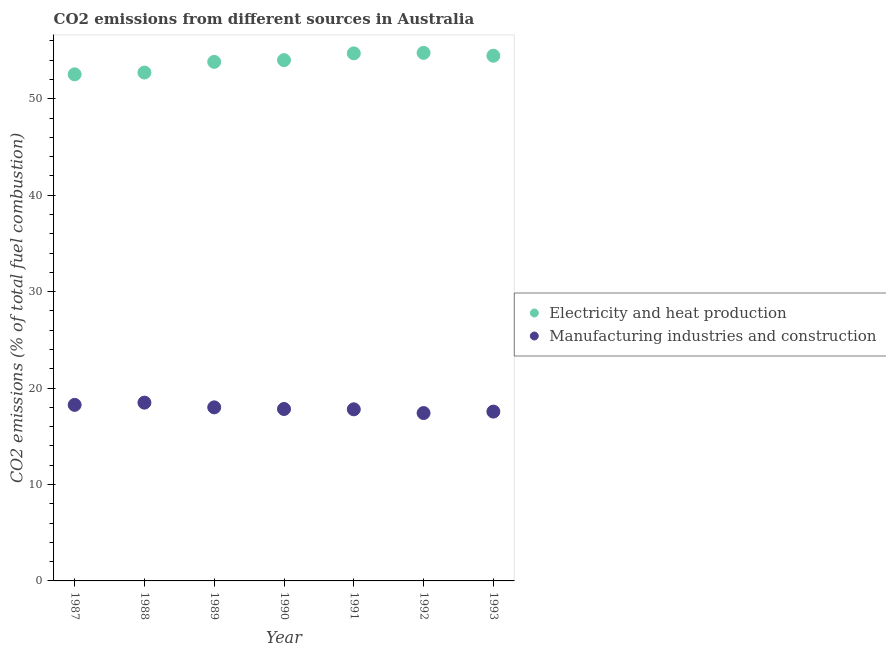Is the number of dotlines equal to the number of legend labels?
Offer a terse response. Yes. What is the co2 emissions due to electricity and heat production in 1993?
Offer a very short reply. 54.46. Across all years, what is the maximum co2 emissions due to electricity and heat production?
Keep it short and to the point. 54.75. Across all years, what is the minimum co2 emissions due to electricity and heat production?
Keep it short and to the point. 52.53. In which year was the co2 emissions due to electricity and heat production maximum?
Give a very brief answer. 1992. What is the total co2 emissions due to electricity and heat production in the graph?
Offer a very short reply. 376.98. What is the difference between the co2 emissions due to manufacturing industries in 1990 and that in 1993?
Offer a terse response. 0.27. What is the difference between the co2 emissions due to manufacturing industries in 1989 and the co2 emissions due to electricity and heat production in 1988?
Ensure brevity in your answer.  -34.72. What is the average co2 emissions due to manufacturing industries per year?
Offer a terse response. 17.9. In the year 1992, what is the difference between the co2 emissions due to manufacturing industries and co2 emissions due to electricity and heat production?
Ensure brevity in your answer.  -37.35. What is the ratio of the co2 emissions due to manufacturing industries in 1989 to that in 1993?
Offer a very short reply. 1.03. Is the co2 emissions due to manufacturing industries in 1989 less than that in 1991?
Offer a terse response. No. Is the difference between the co2 emissions due to manufacturing industries in 1987 and 1989 greater than the difference between the co2 emissions due to electricity and heat production in 1987 and 1989?
Keep it short and to the point. Yes. What is the difference between the highest and the second highest co2 emissions due to manufacturing industries?
Provide a succinct answer. 0.23. What is the difference between the highest and the lowest co2 emissions due to manufacturing industries?
Give a very brief answer. 1.08. Does the co2 emissions due to electricity and heat production monotonically increase over the years?
Offer a terse response. No. Is the co2 emissions due to manufacturing industries strictly greater than the co2 emissions due to electricity and heat production over the years?
Your answer should be very brief. No. How many years are there in the graph?
Ensure brevity in your answer.  7. Are the values on the major ticks of Y-axis written in scientific E-notation?
Provide a succinct answer. No. Where does the legend appear in the graph?
Offer a terse response. Center right. What is the title of the graph?
Keep it short and to the point. CO2 emissions from different sources in Australia. Does "Secondary Education" appear as one of the legend labels in the graph?
Give a very brief answer. No. What is the label or title of the Y-axis?
Your answer should be compact. CO2 emissions (% of total fuel combustion). What is the CO2 emissions (% of total fuel combustion) of Electricity and heat production in 1987?
Make the answer very short. 52.53. What is the CO2 emissions (% of total fuel combustion) of Manufacturing industries and construction in 1987?
Keep it short and to the point. 18.26. What is the CO2 emissions (% of total fuel combustion) of Electricity and heat production in 1988?
Your response must be concise. 52.71. What is the CO2 emissions (% of total fuel combustion) of Manufacturing industries and construction in 1988?
Offer a terse response. 18.49. What is the CO2 emissions (% of total fuel combustion) in Electricity and heat production in 1989?
Give a very brief answer. 53.82. What is the CO2 emissions (% of total fuel combustion) in Manufacturing industries and construction in 1989?
Ensure brevity in your answer.  18. What is the CO2 emissions (% of total fuel combustion) of Electricity and heat production in 1990?
Give a very brief answer. 54. What is the CO2 emissions (% of total fuel combustion) in Manufacturing industries and construction in 1990?
Offer a very short reply. 17.83. What is the CO2 emissions (% of total fuel combustion) in Electricity and heat production in 1991?
Offer a terse response. 54.7. What is the CO2 emissions (% of total fuel combustion) of Manufacturing industries and construction in 1991?
Give a very brief answer. 17.79. What is the CO2 emissions (% of total fuel combustion) of Electricity and heat production in 1992?
Offer a very short reply. 54.75. What is the CO2 emissions (% of total fuel combustion) in Manufacturing industries and construction in 1992?
Your answer should be compact. 17.41. What is the CO2 emissions (% of total fuel combustion) in Electricity and heat production in 1993?
Your answer should be very brief. 54.46. What is the CO2 emissions (% of total fuel combustion) in Manufacturing industries and construction in 1993?
Your answer should be compact. 17.56. Across all years, what is the maximum CO2 emissions (% of total fuel combustion) of Electricity and heat production?
Give a very brief answer. 54.75. Across all years, what is the maximum CO2 emissions (% of total fuel combustion) in Manufacturing industries and construction?
Provide a succinct answer. 18.49. Across all years, what is the minimum CO2 emissions (% of total fuel combustion) in Electricity and heat production?
Give a very brief answer. 52.53. Across all years, what is the minimum CO2 emissions (% of total fuel combustion) of Manufacturing industries and construction?
Make the answer very short. 17.41. What is the total CO2 emissions (% of total fuel combustion) in Electricity and heat production in the graph?
Ensure brevity in your answer.  376.98. What is the total CO2 emissions (% of total fuel combustion) in Manufacturing industries and construction in the graph?
Provide a short and direct response. 125.32. What is the difference between the CO2 emissions (% of total fuel combustion) in Electricity and heat production in 1987 and that in 1988?
Keep it short and to the point. -0.19. What is the difference between the CO2 emissions (% of total fuel combustion) of Manufacturing industries and construction in 1987 and that in 1988?
Your answer should be very brief. -0.23. What is the difference between the CO2 emissions (% of total fuel combustion) of Electricity and heat production in 1987 and that in 1989?
Keep it short and to the point. -1.29. What is the difference between the CO2 emissions (% of total fuel combustion) in Manufacturing industries and construction in 1987 and that in 1989?
Keep it short and to the point. 0.26. What is the difference between the CO2 emissions (% of total fuel combustion) of Electricity and heat production in 1987 and that in 1990?
Provide a short and direct response. -1.47. What is the difference between the CO2 emissions (% of total fuel combustion) of Manufacturing industries and construction in 1987 and that in 1990?
Your answer should be compact. 0.43. What is the difference between the CO2 emissions (% of total fuel combustion) of Electricity and heat production in 1987 and that in 1991?
Provide a succinct answer. -2.18. What is the difference between the CO2 emissions (% of total fuel combustion) of Manufacturing industries and construction in 1987 and that in 1991?
Your answer should be very brief. 0.46. What is the difference between the CO2 emissions (% of total fuel combustion) in Electricity and heat production in 1987 and that in 1992?
Keep it short and to the point. -2.22. What is the difference between the CO2 emissions (% of total fuel combustion) of Manufacturing industries and construction in 1987 and that in 1992?
Your answer should be very brief. 0.85. What is the difference between the CO2 emissions (% of total fuel combustion) of Electricity and heat production in 1987 and that in 1993?
Provide a short and direct response. -1.93. What is the difference between the CO2 emissions (% of total fuel combustion) in Manufacturing industries and construction in 1987 and that in 1993?
Your answer should be very brief. 0.7. What is the difference between the CO2 emissions (% of total fuel combustion) of Electricity and heat production in 1988 and that in 1989?
Provide a succinct answer. -1.11. What is the difference between the CO2 emissions (% of total fuel combustion) in Manufacturing industries and construction in 1988 and that in 1989?
Ensure brevity in your answer.  0.49. What is the difference between the CO2 emissions (% of total fuel combustion) in Electricity and heat production in 1988 and that in 1990?
Your answer should be compact. -1.29. What is the difference between the CO2 emissions (% of total fuel combustion) of Manufacturing industries and construction in 1988 and that in 1990?
Offer a very short reply. 0.66. What is the difference between the CO2 emissions (% of total fuel combustion) of Electricity and heat production in 1988 and that in 1991?
Your answer should be very brief. -1.99. What is the difference between the CO2 emissions (% of total fuel combustion) in Manufacturing industries and construction in 1988 and that in 1991?
Make the answer very short. 0.69. What is the difference between the CO2 emissions (% of total fuel combustion) in Electricity and heat production in 1988 and that in 1992?
Your answer should be very brief. -2.04. What is the difference between the CO2 emissions (% of total fuel combustion) of Manufacturing industries and construction in 1988 and that in 1992?
Your response must be concise. 1.08. What is the difference between the CO2 emissions (% of total fuel combustion) of Electricity and heat production in 1988 and that in 1993?
Provide a succinct answer. -1.74. What is the difference between the CO2 emissions (% of total fuel combustion) of Manufacturing industries and construction in 1988 and that in 1993?
Make the answer very short. 0.93. What is the difference between the CO2 emissions (% of total fuel combustion) of Electricity and heat production in 1989 and that in 1990?
Provide a succinct answer. -0.18. What is the difference between the CO2 emissions (% of total fuel combustion) in Manufacturing industries and construction in 1989 and that in 1990?
Your response must be concise. 0.17. What is the difference between the CO2 emissions (% of total fuel combustion) in Electricity and heat production in 1989 and that in 1991?
Give a very brief answer. -0.88. What is the difference between the CO2 emissions (% of total fuel combustion) of Manufacturing industries and construction in 1989 and that in 1991?
Keep it short and to the point. 0.2. What is the difference between the CO2 emissions (% of total fuel combustion) of Electricity and heat production in 1989 and that in 1992?
Provide a short and direct response. -0.93. What is the difference between the CO2 emissions (% of total fuel combustion) of Manufacturing industries and construction in 1989 and that in 1992?
Keep it short and to the point. 0.59. What is the difference between the CO2 emissions (% of total fuel combustion) of Electricity and heat production in 1989 and that in 1993?
Provide a short and direct response. -0.63. What is the difference between the CO2 emissions (% of total fuel combustion) in Manufacturing industries and construction in 1989 and that in 1993?
Offer a very short reply. 0.44. What is the difference between the CO2 emissions (% of total fuel combustion) of Electricity and heat production in 1990 and that in 1991?
Ensure brevity in your answer.  -0.7. What is the difference between the CO2 emissions (% of total fuel combustion) in Manufacturing industries and construction in 1990 and that in 1991?
Offer a very short reply. 0.03. What is the difference between the CO2 emissions (% of total fuel combustion) of Electricity and heat production in 1990 and that in 1992?
Offer a terse response. -0.75. What is the difference between the CO2 emissions (% of total fuel combustion) of Manufacturing industries and construction in 1990 and that in 1992?
Offer a terse response. 0.42. What is the difference between the CO2 emissions (% of total fuel combustion) in Electricity and heat production in 1990 and that in 1993?
Your answer should be compact. -0.46. What is the difference between the CO2 emissions (% of total fuel combustion) of Manufacturing industries and construction in 1990 and that in 1993?
Keep it short and to the point. 0.27. What is the difference between the CO2 emissions (% of total fuel combustion) of Electricity and heat production in 1991 and that in 1992?
Your answer should be compact. -0.05. What is the difference between the CO2 emissions (% of total fuel combustion) of Manufacturing industries and construction in 1991 and that in 1992?
Give a very brief answer. 0.39. What is the difference between the CO2 emissions (% of total fuel combustion) of Electricity and heat production in 1991 and that in 1993?
Provide a succinct answer. 0.25. What is the difference between the CO2 emissions (% of total fuel combustion) of Manufacturing industries and construction in 1991 and that in 1993?
Your answer should be very brief. 0.24. What is the difference between the CO2 emissions (% of total fuel combustion) in Electricity and heat production in 1992 and that in 1993?
Provide a succinct answer. 0.3. What is the difference between the CO2 emissions (% of total fuel combustion) in Manufacturing industries and construction in 1992 and that in 1993?
Make the answer very short. -0.15. What is the difference between the CO2 emissions (% of total fuel combustion) in Electricity and heat production in 1987 and the CO2 emissions (% of total fuel combustion) in Manufacturing industries and construction in 1988?
Your response must be concise. 34.04. What is the difference between the CO2 emissions (% of total fuel combustion) in Electricity and heat production in 1987 and the CO2 emissions (% of total fuel combustion) in Manufacturing industries and construction in 1989?
Give a very brief answer. 34.53. What is the difference between the CO2 emissions (% of total fuel combustion) in Electricity and heat production in 1987 and the CO2 emissions (% of total fuel combustion) in Manufacturing industries and construction in 1990?
Your response must be concise. 34.7. What is the difference between the CO2 emissions (% of total fuel combustion) in Electricity and heat production in 1987 and the CO2 emissions (% of total fuel combustion) in Manufacturing industries and construction in 1991?
Your answer should be compact. 34.73. What is the difference between the CO2 emissions (% of total fuel combustion) of Electricity and heat production in 1987 and the CO2 emissions (% of total fuel combustion) of Manufacturing industries and construction in 1992?
Your answer should be very brief. 35.12. What is the difference between the CO2 emissions (% of total fuel combustion) in Electricity and heat production in 1987 and the CO2 emissions (% of total fuel combustion) in Manufacturing industries and construction in 1993?
Provide a succinct answer. 34.97. What is the difference between the CO2 emissions (% of total fuel combustion) of Electricity and heat production in 1988 and the CO2 emissions (% of total fuel combustion) of Manufacturing industries and construction in 1989?
Ensure brevity in your answer.  34.72. What is the difference between the CO2 emissions (% of total fuel combustion) in Electricity and heat production in 1988 and the CO2 emissions (% of total fuel combustion) in Manufacturing industries and construction in 1990?
Ensure brevity in your answer.  34.89. What is the difference between the CO2 emissions (% of total fuel combustion) of Electricity and heat production in 1988 and the CO2 emissions (% of total fuel combustion) of Manufacturing industries and construction in 1991?
Your answer should be compact. 34.92. What is the difference between the CO2 emissions (% of total fuel combustion) in Electricity and heat production in 1988 and the CO2 emissions (% of total fuel combustion) in Manufacturing industries and construction in 1992?
Provide a succinct answer. 35.31. What is the difference between the CO2 emissions (% of total fuel combustion) in Electricity and heat production in 1988 and the CO2 emissions (% of total fuel combustion) in Manufacturing industries and construction in 1993?
Your answer should be very brief. 35.16. What is the difference between the CO2 emissions (% of total fuel combustion) of Electricity and heat production in 1989 and the CO2 emissions (% of total fuel combustion) of Manufacturing industries and construction in 1990?
Provide a short and direct response. 36. What is the difference between the CO2 emissions (% of total fuel combustion) in Electricity and heat production in 1989 and the CO2 emissions (% of total fuel combustion) in Manufacturing industries and construction in 1991?
Provide a short and direct response. 36.03. What is the difference between the CO2 emissions (% of total fuel combustion) of Electricity and heat production in 1989 and the CO2 emissions (% of total fuel combustion) of Manufacturing industries and construction in 1992?
Keep it short and to the point. 36.42. What is the difference between the CO2 emissions (% of total fuel combustion) in Electricity and heat production in 1989 and the CO2 emissions (% of total fuel combustion) in Manufacturing industries and construction in 1993?
Your answer should be compact. 36.27. What is the difference between the CO2 emissions (% of total fuel combustion) of Electricity and heat production in 1990 and the CO2 emissions (% of total fuel combustion) of Manufacturing industries and construction in 1991?
Make the answer very short. 36.21. What is the difference between the CO2 emissions (% of total fuel combustion) of Electricity and heat production in 1990 and the CO2 emissions (% of total fuel combustion) of Manufacturing industries and construction in 1992?
Provide a short and direct response. 36.59. What is the difference between the CO2 emissions (% of total fuel combustion) in Electricity and heat production in 1990 and the CO2 emissions (% of total fuel combustion) in Manufacturing industries and construction in 1993?
Your answer should be compact. 36.44. What is the difference between the CO2 emissions (% of total fuel combustion) of Electricity and heat production in 1991 and the CO2 emissions (% of total fuel combustion) of Manufacturing industries and construction in 1992?
Give a very brief answer. 37.3. What is the difference between the CO2 emissions (% of total fuel combustion) of Electricity and heat production in 1991 and the CO2 emissions (% of total fuel combustion) of Manufacturing industries and construction in 1993?
Your response must be concise. 37.15. What is the difference between the CO2 emissions (% of total fuel combustion) in Electricity and heat production in 1992 and the CO2 emissions (% of total fuel combustion) in Manufacturing industries and construction in 1993?
Offer a terse response. 37.2. What is the average CO2 emissions (% of total fuel combustion) of Electricity and heat production per year?
Offer a very short reply. 53.85. What is the average CO2 emissions (% of total fuel combustion) in Manufacturing industries and construction per year?
Your answer should be very brief. 17.9. In the year 1987, what is the difference between the CO2 emissions (% of total fuel combustion) of Electricity and heat production and CO2 emissions (% of total fuel combustion) of Manufacturing industries and construction?
Offer a terse response. 34.27. In the year 1988, what is the difference between the CO2 emissions (% of total fuel combustion) in Electricity and heat production and CO2 emissions (% of total fuel combustion) in Manufacturing industries and construction?
Provide a succinct answer. 34.23. In the year 1989, what is the difference between the CO2 emissions (% of total fuel combustion) of Electricity and heat production and CO2 emissions (% of total fuel combustion) of Manufacturing industries and construction?
Make the answer very short. 35.83. In the year 1990, what is the difference between the CO2 emissions (% of total fuel combustion) of Electricity and heat production and CO2 emissions (% of total fuel combustion) of Manufacturing industries and construction?
Provide a succinct answer. 36.17. In the year 1991, what is the difference between the CO2 emissions (% of total fuel combustion) in Electricity and heat production and CO2 emissions (% of total fuel combustion) in Manufacturing industries and construction?
Keep it short and to the point. 36.91. In the year 1992, what is the difference between the CO2 emissions (% of total fuel combustion) in Electricity and heat production and CO2 emissions (% of total fuel combustion) in Manufacturing industries and construction?
Make the answer very short. 37.35. In the year 1993, what is the difference between the CO2 emissions (% of total fuel combustion) in Electricity and heat production and CO2 emissions (% of total fuel combustion) in Manufacturing industries and construction?
Your answer should be compact. 36.9. What is the ratio of the CO2 emissions (% of total fuel combustion) in Electricity and heat production in 1987 to that in 1988?
Your answer should be very brief. 1. What is the ratio of the CO2 emissions (% of total fuel combustion) of Manufacturing industries and construction in 1987 to that in 1988?
Make the answer very short. 0.99. What is the ratio of the CO2 emissions (% of total fuel combustion) in Electricity and heat production in 1987 to that in 1989?
Offer a very short reply. 0.98. What is the ratio of the CO2 emissions (% of total fuel combustion) in Manufacturing industries and construction in 1987 to that in 1989?
Keep it short and to the point. 1.01. What is the ratio of the CO2 emissions (% of total fuel combustion) in Electricity and heat production in 1987 to that in 1990?
Offer a terse response. 0.97. What is the ratio of the CO2 emissions (% of total fuel combustion) of Manufacturing industries and construction in 1987 to that in 1990?
Offer a terse response. 1.02. What is the ratio of the CO2 emissions (% of total fuel combustion) in Electricity and heat production in 1987 to that in 1991?
Make the answer very short. 0.96. What is the ratio of the CO2 emissions (% of total fuel combustion) in Manufacturing industries and construction in 1987 to that in 1991?
Give a very brief answer. 1.03. What is the ratio of the CO2 emissions (% of total fuel combustion) in Electricity and heat production in 1987 to that in 1992?
Make the answer very short. 0.96. What is the ratio of the CO2 emissions (% of total fuel combustion) of Manufacturing industries and construction in 1987 to that in 1992?
Ensure brevity in your answer.  1.05. What is the ratio of the CO2 emissions (% of total fuel combustion) of Electricity and heat production in 1987 to that in 1993?
Your answer should be compact. 0.96. What is the ratio of the CO2 emissions (% of total fuel combustion) of Manufacturing industries and construction in 1987 to that in 1993?
Your response must be concise. 1.04. What is the ratio of the CO2 emissions (% of total fuel combustion) of Electricity and heat production in 1988 to that in 1989?
Provide a succinct answer. 0.98. What is the ratio of the CO2 emissions (% of total fuel combustion) in Manufacturing industries and construction in 1988 to that in 1989?
Your answer should be compact. 1.03. What is the ratio of the CO2 emissions (% of total fuel combustion) in Electricity and heat production in 1988 to that in 1990?
Offer a terse response. 0.98. What is the ratio of the CO2 emissions (% of total fuel combustion) in Manufacturing industries and construction in 1988 to that in 1990?
Keep it short and to the point. 1.04. What is the ratio of the CO2 emissions (% of total fuel combustion) in Electricity and heat production in 1988 to that in 1991?
Offer a very short reply. 0.96. What is the ratio of the CO2 emissions (% of total fuel combustion) in Manufacturing industries and construction in 1988 to that in 1991?
Provide a short and direct response. 1.04. What is the ratio of the CO2 emissions (% of total fuel combustion) of Electricity and heat production in 1988 to that in 1992?
Offer a terse response. 0.96. What is the ratio of the CO2 emissions (% of total fuel combustion) in Manufacturing industries and construction in 1988 to that in 1992?
Give a very brief answer. 1.06. What is the ratio of the CO2 emissions (% of total fuel combustion) of Electricity and heat production in 1988 to that in 1993?
Your answer should be compact. 0.97. What is the ratio of the CO2 emissions (% of total fuel combustion) in Manufacturing industries and construction in 1988 to that in 1993?
Your answer should be very brief. 1.05. What is the ratio of the CO2 emissions (% of total fuel combustion) of Electricity and heat production in 1989 to that in 1990?
Provide a short and direct response. 1. What is the ratio of the CO2 emissions (% of total fuel combustion) in Manufacturing industries and construction in 1989 to that in 1990?
Offer a terse response. 1.01. What is the ratio of the CO2 emissions (% of total fuel combustion) in Electricity and heat production in 1989 to that in 1991?
Your answer should be compact. 0.98. What is the ratio of the CO2 emissions (% of total fuel combustion) of Manufacturing industries and construction in 1989 to that in 1991?
Provide a succinct answer. 1.01. What is the ratio of the CO2 emissions (% of total fuel combustion) in Manufacturing industries and construction in 1989 to that in 1992?
Keep it short and to the point. 1.03. What is the ratio of the CO2 emissions (% of total fuel combustion) of Electricity and heat production in 1989 to that in 1993?
Your answer should be very brief. 0.99. What is the ratio of the CO2 emissions (% of total fuel combustion) of Electricity and heat production in 1990 to that in 1991?
Provide a short and direct response. 0.99. What is the ratio of the CO2 emissions (% of total fuel combustion) of Electricity and heat production in 1990 to that in 1992?
Make the answer very short. 0.99. What is the ratio of the CO2 emissions (% of total fuel combustion) in Manufacturing industries and construction in 1990 to that in 1992?
Your answer should be very brief. 1.02. What is the ratio of the CO2 emissions (% of total fuel combustion) in Electricity and heat production in 1990 to that in 1993?
Your response must be concise. 0.99. What is the ratio of the CO2 emissions (% of total fuel combustion) in Manufacturing industries and construction in 1990 to that in 1993?
Give a very brief answer. 1.02. What is the ratio of the CO2 emissions (% of total fuel combustion) of Manufacturing industries and construction in 1991 to that in 1992?
Provide a short and direct response. 1.02. What is the ratio of the CO2 emissions (% of total fuel combustion) of Electricity and heat production in 1991 to that in 1993?
Keep it short and to the point. 1. What is the ratio of the CO2 emissions (% of total fuel combustion) of Manufacturing industries and construction in 1991 to that in 1993?
Provide a succinct answer. 1.01. What is the ratio of the CO2 emissions (% of total fuel combustion) in Electricity and heat production in 1992 to that in 1993?
Your answer should be compact. 1.01. What is the ratio of the CO2 emissions (% of total fuel combustion) of Manufacturing industries and construction in 1992 to that in 1993?
Provide a short and direct response. 0.99. What is the difference between the highest and the second highest CO2 emissions (% of total fuel combustion) of Electricity and heat production?
Give a very brief answer. 0.05. What is the difference between the highest and the second highest CO2 emissions (% of total fuel combustion) of Manufacturing industries and construction?
Keep it short and to the point. 0.23. What is the difference between the highest and the lowest CO2 emissions (% of total fuel combustion) in Electricity and heat production?
Ensure brevity in your answer.  2.22. What is the difference between the highest and the lowest CO2 emissions (% of total fuel combustion) of Manufacturing industries and construction?
Your answer should be compact. 1.08. 